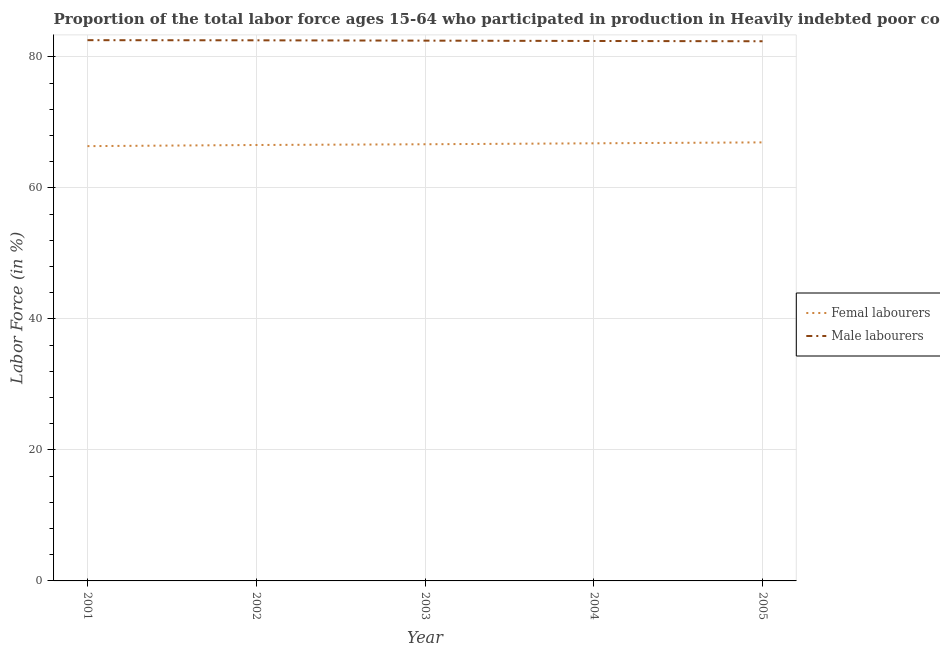Is the number of lines equal to the number of legend labels?
Provide a short and direct response. Yes. What is the percentage of male labour force in 2003?
Offer a terse response. 82.49. Across all years, what is the maximum percentage of female labor force?
Give a very brief answer. 66.95. Across all years, what is the minimum percentage of female labor force?
Provide a short and direct response. 66.38. In which year was the percentage of female labor force maximum?
Your answer should be very brief. 2005. In which year was the percentage of female labor force minimum?
Ensure brevity in your answer.  2001. What is the total percentage of male labour force in the graph?
Ensure brevity in your answer.  412.41. What is the difference between the percentage of female labor force in 2001 and that in 2005?
Your answer should be compact. -0.57. What is the difference between the percentage of male labour force in 2002 and the percentage of female labor force in 2001?
Keep it short and to the point. 16.16. What is the average percentage of male labour force per year?
Keep it short and to the point. 82.48. In the year 2003, what is the difference between the percentage of male labour force and percentage of female labor force?
Your answer should be very brief. 15.82. What is the ratio of the percentage of female labor force in 2001 to that in 2005?
Offer a very short reply. 0.99. Is the difference between the percentage of male labour force in 2001 and 2005 greater than the difference between the percentage of female labor force in 2001 and 2005?
Give a very brief answer. Yes. What is the difference between the highest and the second highest percentage of male labour force?
Your answer should be compact. 0.02. What is the difference between the highest and the lowest percentage of female labor force?
Offer a very short reply. 0.57. In how many years, is the percentage of male labour force greater than the average percentage of male labour force taken over all years?
Offer a very short reply. 3. Is the sum of the percentage of male labour force in 2001 and 2002 greater than the maximum percentage of female labor force across all years?
Offer a very short reply. Yes. Is the percentage of female labor force strictly greater than the percentage of male labour force over the years?
Keep it short and to the point. No. Is the percentage of male labour force strictly less than the percentage of female labor force over the years?
Offer a very short reply. No. What is the difference between two consecutive major ticks on the Y-axis?
Ensure brevity in your answer.  20. Are the values on the major ticks of Y-axis written in scientific E-notation?
Your answer should be compact. No. Does the graph contain any zero values?
Offer a terse response. No. Does the graph contain grids?
Make the answer very short. Yes. How many legend labels are there?
Your response must be concise. 2. How are the legend labels stacked?
Your answer should be compact. Vertical. What is the title of the graph?
Give a very brief answer. Proportion of the total labor force ages 15-64 who participated in production in Heavily indebted poor countries. Does "Primary education" appear as one of the legend labels in the graph?
Provide a succinct answer. No. What is the label or title of the X-axis?
Provide a succinct answer. Year. What is the label or title of the Y-axis?
Provide a succinct answer. Labor Force (in %). What is the Labor Force (in %) in Femal labourers in 2001?
Your answer should be compact. 66.38. What is the Labor Force (in %) of Male labourers in 2001?
Offer a very short reply. 82.56. What is the Labor Force (in %) of Femal labourers in 2002?
Make the answer very short. 66.55. What is the Labor Force (in %) in Male labourers in 2002?
Provide a short and direct response. 82.54. What is the Labor Force (in %) of Femal labourers in 2003?
Provide a short and direct response. 66.67. What is the Labor Force (in %) of Male labourers in 2003?
Your answer should be very brief. 82.49. What is the Labor Force (in %) of Femal labourers in 2004?
Offer a very short reply. 66.81. What is the Labor Force (in %) in Male labourers in 2004?
Keep it short and to the point. 82.43. What is the Labor Force (in %) of Femal labourers in 2005?
Offer a very short reply. 66.95. What is the Labor Force (in %) of Male labourers in 2005?
Offer a terse response. 82.39. Across all years, what is the maximum Labor Force (in %) in Femal labourers?
Your answer should be very brief. 66.95. Across all years, what is the maximum Labor Force (in %) in Male labourers?
Your answer should be compact. 82.56. Across all years, what is the minimum Labor Force (in %) of Femal labourers?
Your answer should be very brief. 66.38. Across all years, what is the minimum Labor Force (in %) in Male labourers?
Your answer should be very brief. 82.39. What is the total Labor Force (in %) of Femal labourers in the graph?
Ensure brevity in your answer.  333.37. What is the total Labor Force (in %) of Male labourers in the graph?
Your answer should be compact. 412.41. What is the difference between the Labor Force (in %) in Femal labourers in 2001 and that in 2002?
Your answer should be compact. -0.17. What is the difference between the Labor Force (in %) of Male labourers in 2001 and that in 2002?
Make the answer very short. 0.02. What is the difference between the Labor Force (in %) of Femal labourers in 2001 and that in 2003?
Give a very brief answer. -0.29. What is the difference between the Labor Force (in %) of Male labourers in 2001 and that in 2003?
Provide a short and direct response. 0.07. What is the difference between the Labor Force (in %) of Femal labourers in 2001 and that in 2004?
Your answer should be very brief. -0.43. What is the difference between the Labor Force (in %) of Male labourers in 2001 and that in 2004?
Ensure brevity in your answer.  0.12. What is the difference between the Labor Force (in %) in Femal labourers in 2001 and that in 2005?
Your answer should be very brief. -0.57. What is the difference between the Labor Force (in %) in Male labourers in 2001 and that in 2005?
Provide a short and direct response. 0.17. What is the difference between the Labor Force (in %) of Femal labourers in 2002 and that in 2003?
Offer a terse response. -0.11. What is the difference between the Labor Force (in %) of Male labourers in 2002 and that in 2003?
Your response must be concise. 0.05. What is the difference between the Labor Force (in %) in Femal labourers in 2002 and that in 2004?
Provide a short and direct response. -0.26. What is the difference between the Labor Force (in %) of Male labourers in 2002 and that in 2004?
Offer a terse response. 0.1. What is the difference between the Labor Force (in %) of Femal labourers in 2002 and that in 2005?
Offer a very short reply. -0.4. What is the difference between the Labor Force (in %) of Male labourers in 2002 and that in 2005?
Offer a terse response. 0.14. What is the difference between the Labor Force (in %) of Femal labourers in 2003 and that in 2004?
Keep it short and to the point. -0.15. What is the difference between the Labor Force (in %) in Male labourers in 2003 and that in 2004?
Your answer should be very brief. 0.05. What is the difference between the Labor Force (in %) of Femal labourers in 2003 and that in 2005?
Make the answer very short. -0.29. What is the difference between the Labor Force (in %) of Male labourers in 2003 and that in 2005?
Provide a succinct answer. 0.09. What is the difference between the Labor Force (in %) of Femal labourers in 2004 and that in 2005?
Offer a terse response. -0.14. What is the difference between the Labor Force (in %) of Male labourers in 2004 and that in 2005?
Give a very brief answer. 0.04. What is the difference between the Labor Force (in %) in Femal labourers in 2001 and the Labor Force (in %) in Male labourers in 2002?
Ensure brevity in your answer.  -16.16. What is the difference between the Labor Force (in %) in Femal labourers in 2001 and the Labor Force (in %) in Male labourers in 2003?
Your answer should be very brief. -16.11. What is the difference between the Labor Force (in %) of Femal labourers in 2001 and the Labor Force (in %) of Male labourers in 2004?
Your answer should be very brief. -16.05. What is the difference between the Labor Force (in %) in Femal labourers in 2001 and the Labor Force (in %) in Male labourers in 2005?
Keep it short and to the point. -16.01. What is the difference between the Labor Force (in %) of Femal labourers in 2002 and the Labor Force (in %) of Male labourers in 2003?
Your response must be concise. -15.93. What is the difference between the Labor Force (in %) of Femal labourers in 2002 and the Labor Force (in %) of Male labourers in 2004?
Your answer should be very brief. -15.88. What is the difference between the Labor Force (in %) in Femal labourers in 2002 and the Labor Force (in %) in Male labourers in 2005?
Make the answer very short. -15.84. What is the difference between the Labor Force (in %) of Femal labourers in 2003 and the Labor Force (in %) of Male labourers in 2004?
Provide a succinct answer. -15.77. What is the difference between the Labor Force (in %) of Femal labourers in 2003 and the Labor Force (in %) of Male labourers in 2005?
Ensure brevity in your answer.  -15.73. What is the difference between the Labor Force (in %) of Femal labourers in 2004 and the Labor Force (in %) of Male labourers in 2005?
Keep it short and to the point. -15.58. What is the average Labor Force (in %) in Femal labourers per year?
Provide a short and direct response. 66.67. What is the average Labor Force (in %) in Male labourers per year?
Provide a succinct answer. 82.48. In the year 2001, what is the difference between the Labor Force (in %) of Femal labourers and Labor Force (in %) of Male labourers?
Your answer should be compact. -16.18. In the year 2002, what is the difference between the Labor Force (in %) of Femal labourers and Labor Force (in %) of Male labourers?
Make the answer very short. -15.98. In the year 2003, what is the difference between the Labor Force (in %) of Femal labourers and Labor Force (in %) of Male labourers?
Make the answer very short. -15.82. In the year 2004, what is the difference between the Labor Force (in %) of Femal labourers and Labor Force (in %) of Male labourers?
Your response must be concise. -15.62. In the year 2005, what is the difference between the Labor Force (in %) in Femal labourers and Labor Force (in %) in Male labourers?
Your response must be concise. -15.44. What is the ratio of the Labor Force (in %) in Femal labourers in 2001 to that in 2002?
Offer a terse response. 1. What is the ratio of the Labor Force (in %) in Male labourers in 2001 to that in 2003?
Your response must be concise. 1. What is the ratio of the Labor Force (in %) in Male labourers in 2002 to that in 2004?
Your answer should be compact. 1. What is the ratio of the Labor Force (in %) of Femal labourers in 2002 to that in 2005?
Your response must be concise. 0.99. What is the ratio of the Labor Force (in %) in Male labourers in 2002 to that in 2005?
Your response must be concise. 1. What is the ratio of the Labor Force (in %) in Femal labourers in 2003 to that in 2004?
Your response must be concise. 1. What is the ratio of the Labor Force (in %) of Male labourers in 2003 to that in 2005?
Provide a short and direct response. 1. What is the ratio of the Labor Force (in %) in Femal labourers in 2004 to that in 2005?
Provide a succinct answer. 1. What is the difference between the highest and the second highest Labor Force (in %) in Femal labourers?
Make the answer very short. 0.14. What is the difference between the highest and the second highest Labor Force (in %) in Male labourers?
Your answer should be very brief. 0.02. What is the difference between the highest and the lowest Labor Force (in %) in Femal labourers?
Ensure brevity in your answer.  0.57. What is the difference between the highest and the lowest Labor Force (in %) in Male labourers?
Give a very brief answer. 0.17. 